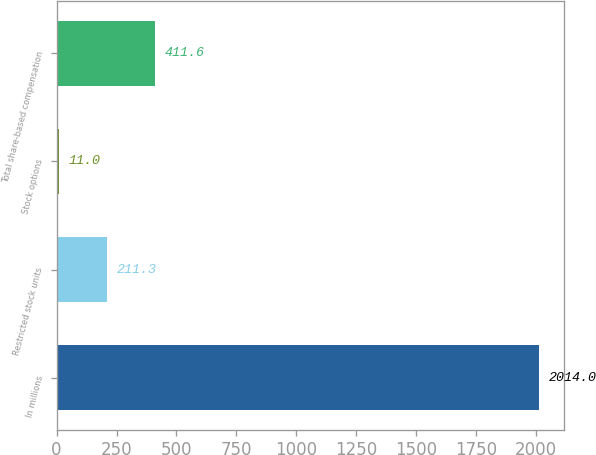<chart> <loc_0><loc_0><loc_500><loc_500><bar_chart><fcel>In millions<fcel>Restricted stock units<fcel>Stock options<fcel>Total share-based compensation<nl><fcel>2014<fcel>211.3<fcel>11<fcel>411.6<nl></chart> 